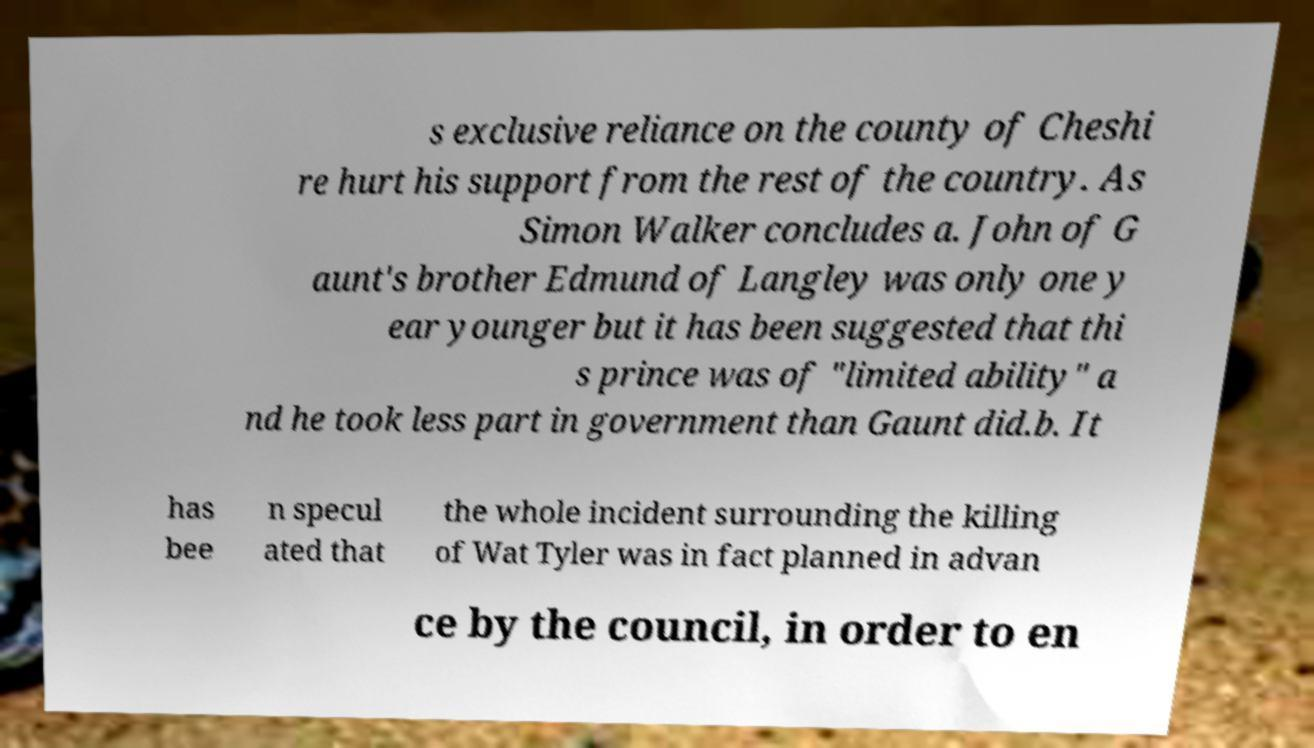Please identify and transcribe the text found in this image. s exclusive reliance on the county of Cheshi re hurt his support from the rest of the country. As Simon Walker concludes a. John of G aunt's brother Edmund of Langley was only one y ear younger but it has been suggested that thi s prince was of "limited ability" a nd he took less part in government than Gaunt did.b. It has bee n specul ated that the whole incident surrounding the killing of Wat Tyler was in fact planned in advan ce by the council, in order to en 